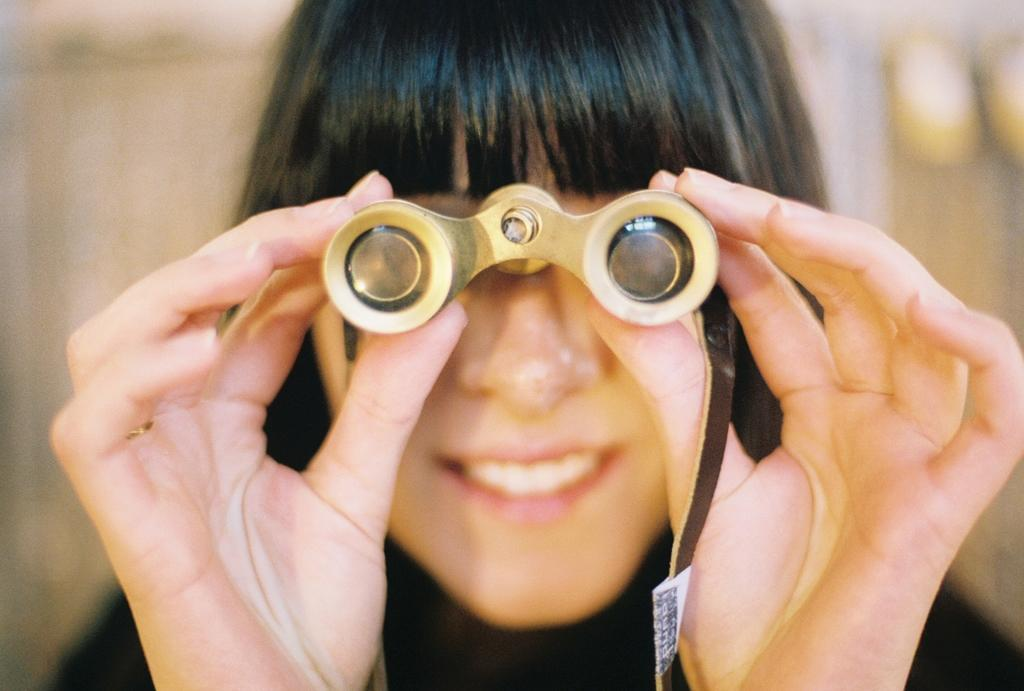Who is the main subject in the image? There is a woman in the image. What is the woman holding in the image? The woman is holding binoculars. Can you describe the background of the image? The background of the image is blurry. What type of account does the woman have with the boats in the image? There are no boats present in the image, and therefore no account can be associated with them. 